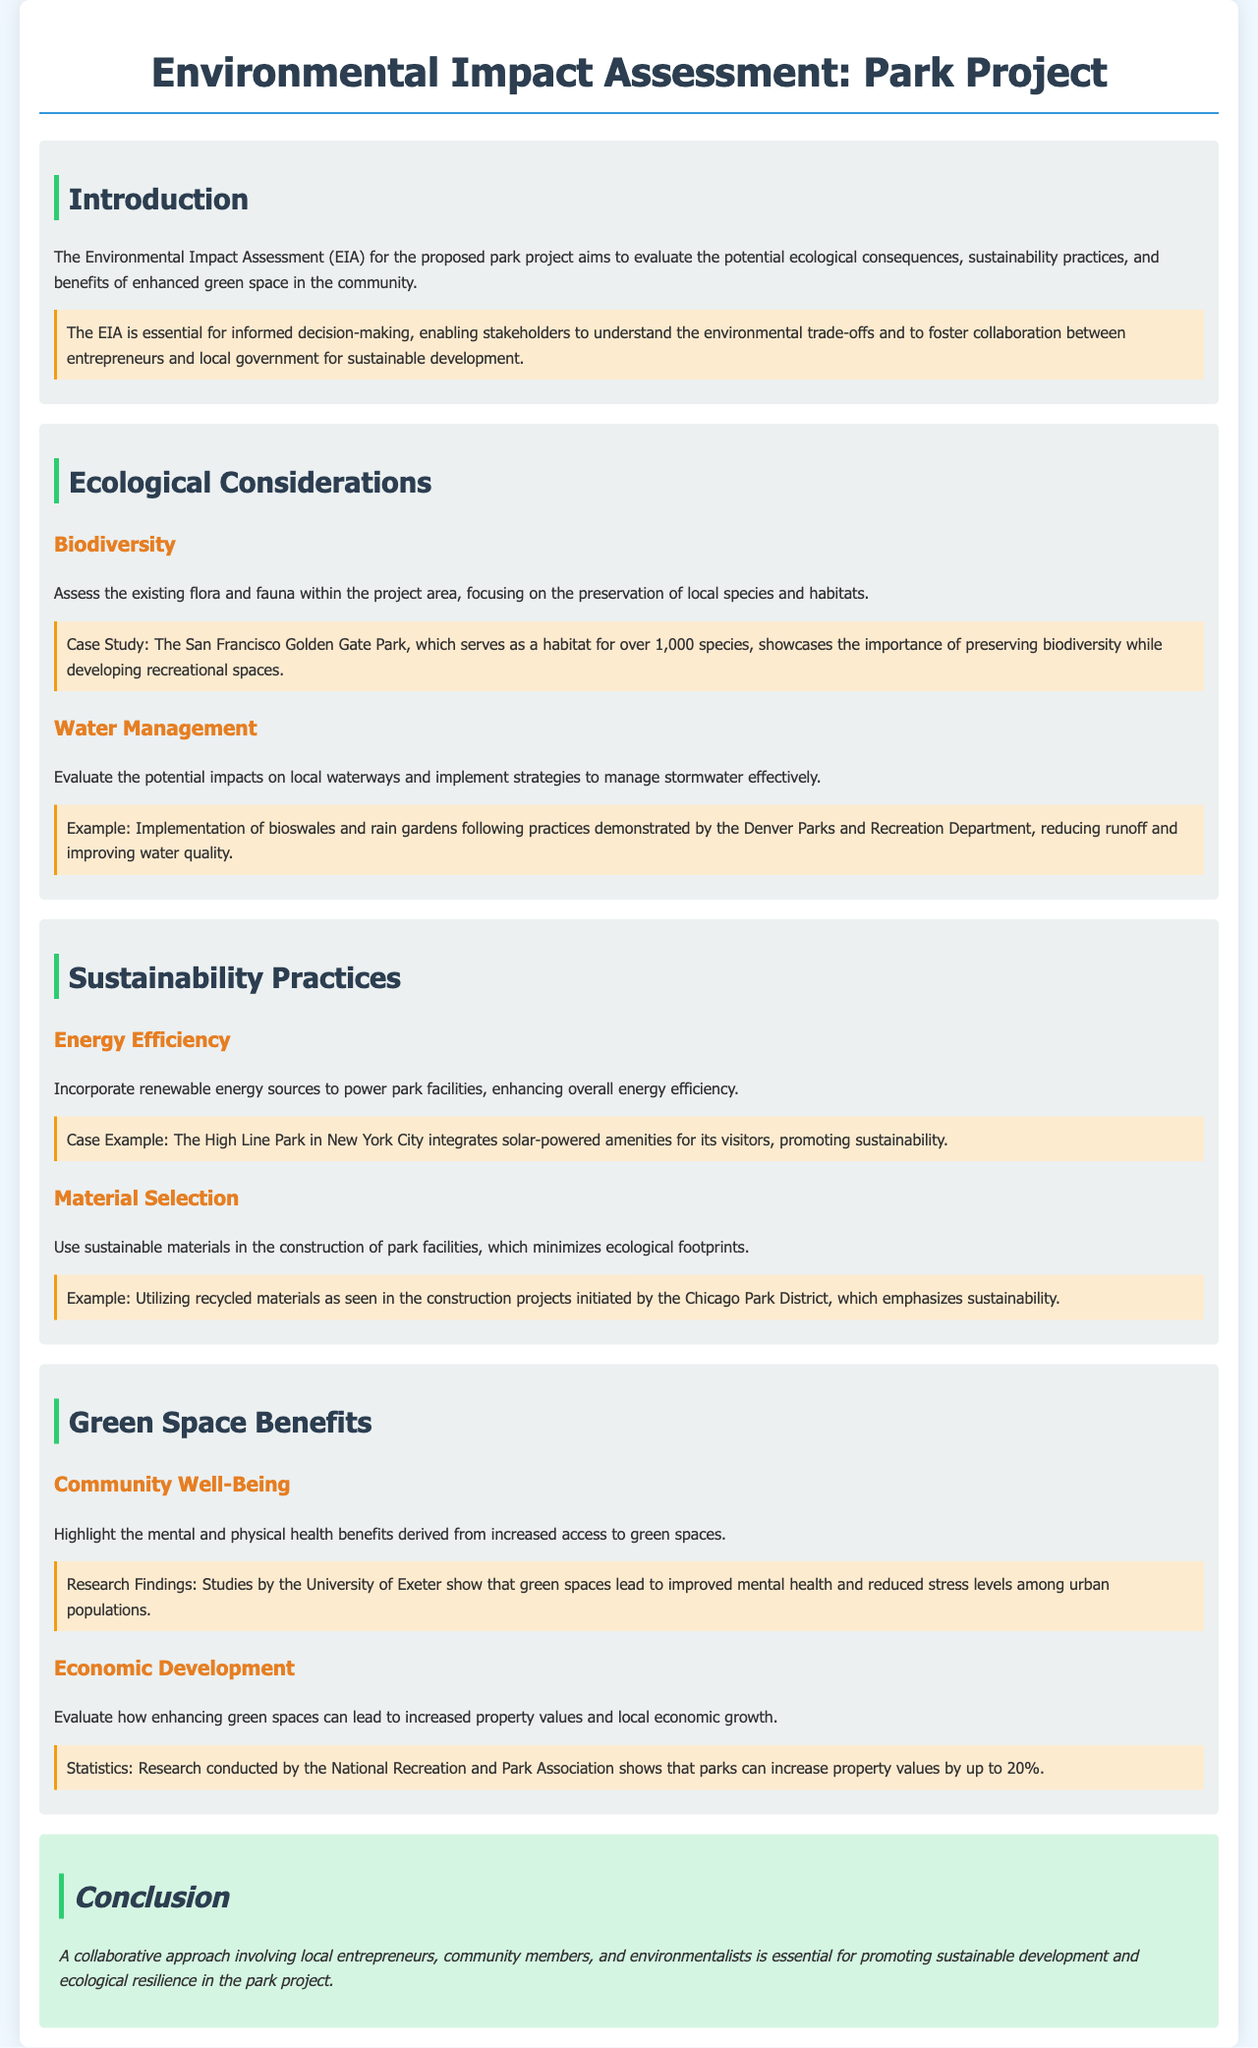what is the primary aim of the Environmental Impact Assessment? The primary aim of the EIA is to evaluate the potential ecological consequences, sustainability practices, and benefits of enhanced green space in the community.
Answer: evaluate the potential ecological consequences how many species does the San Francisco Golden Gate Park serve as a habitat for? The document states that the San Francisco Golden Gate Park serves as a habitat for over 1,000 species.
Answer: over 1,000 species what does the implementation of bioswales and rain gardens help improve? The document mentions that implementing bioswales and rain gardens helps reduce runoff and improve water quality.
Answer: water quality which park integrates solar-powered amenities? The case example of the park that integrates solar-powered amenities is the High Line Park in New York City.
Answer: High Line Park what percentage can parks potentially increase property values by? The document states that research shows parks can increase property values by up to 20%.
Answer: up to 20% what is crucial for promoting sustainable development in the park project? The conclusion emphasizes that a collaborative approach involving local entrepreneurs, community members, and environmentalists is essential for promoting sustainable development.
Answer: collaborative approach what significant mental health benefit is linked to increased access to green spaces? Studies indicate that increased access to green spaces leads to improved mental health.
Answer: improved mental health 